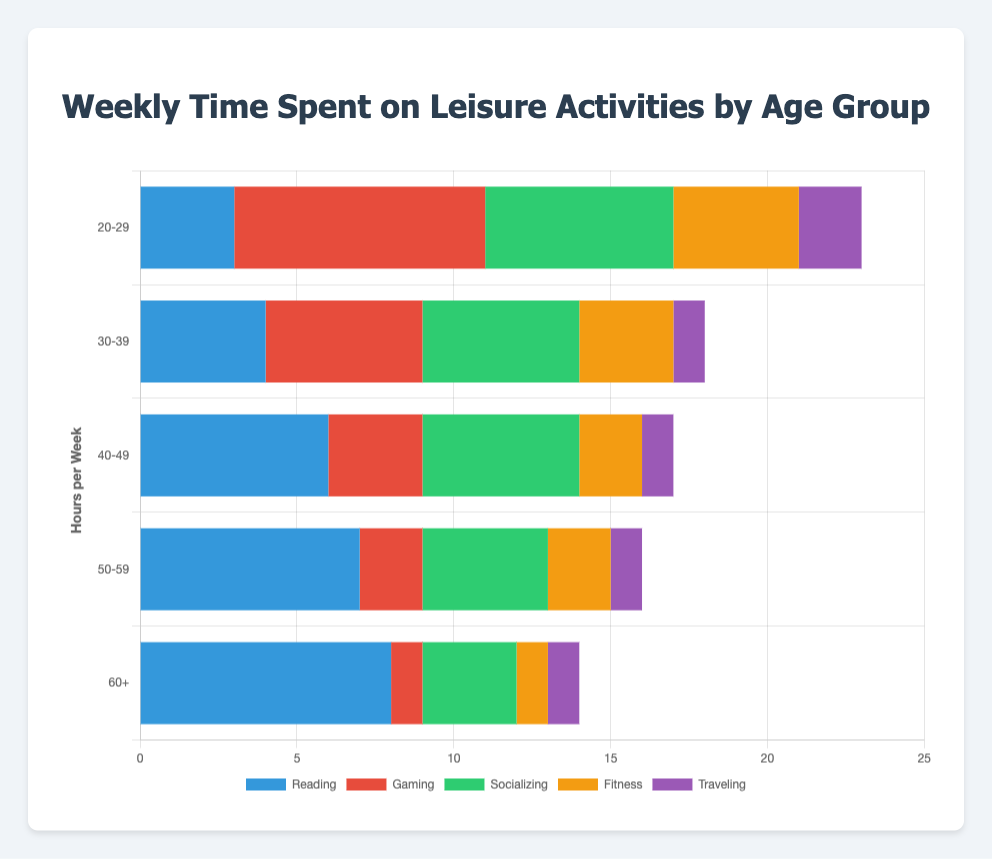What is the total time spent on leisure activities for the age group 20-29? Sum up the values for all activities in the 20-29 age group: 3 (Reading) + 8 (Gaming) + 6 (Socializing) + 4 (Fitness) + 2 (Traveling) = 23 hours
Answer: 23 Which age group spends the most time socializing? Compare the socializing bars across all age groups. The values are: 20-29 (6), 30-39 (5), 40-49 (5), 50-59 (4), 60+ (3). The highest value is 6 in the age group 20-29
Answer: 20-29 Which leisure activity generally sees an increase in time spent with increasing age? Compare the values of each activity across age groups. Only Reading shows an increasing trend: 20-29 (3), 30-39 (4), 40-49 (6), 50-59 (7), 60+ (8)
Answer: Reading What is the difference in time spent on gaming between the age groups 20-29 and 30-39? Calculate the difference for gaming between the two age groups: 20-29 (8) - 30-39 (5) = 3 hours
Answer: 3 Which leisure activity has the least variation in time spent across all age groups? Assess the range (max - min) for each activity. Reading: 8-3=5, Gaming: 8-1=7, Socializing: 6-3=3, Fitness: 4-1=3, Traveling: 2-1=1. Traveling has the least variation with a range of 1 hour
Answer: Traveling How much more time does the 60+ age group spend reading compared to gaming? Calculate the difference between reading and gaming times for the 60+ age group: 8 (Reading) - 1 (Gaming) = 7 hours
Answer: 7 What percentage of the total leisure time is spent on fitness by the 40-49 age group? Calculate the total leisure time for the 40-49 age group: 6 (Reading) + 3 (Gaming) + 5 (Socializing) + 2 (Fitness) + 1 (Traveling) = 17. Then find the fitness percentage: (2 / 17) * 100 ≈ 11.76%
Answer: 11.76 Which age group spends the least amount of time on traveling? Compare the traveling bars across all age groups. All age groups except 20-29 spend 1 hour, which is the smallest value
Answer: 30-39, 40-49, 50-59, 60+ Is the amount of time spent on socializing the same for the age groups 30-39 and 40-49? Compare the values for socializing in the age groups 30-39 (5) and 40-49 (5). Both values are the same
Answer: Yes 